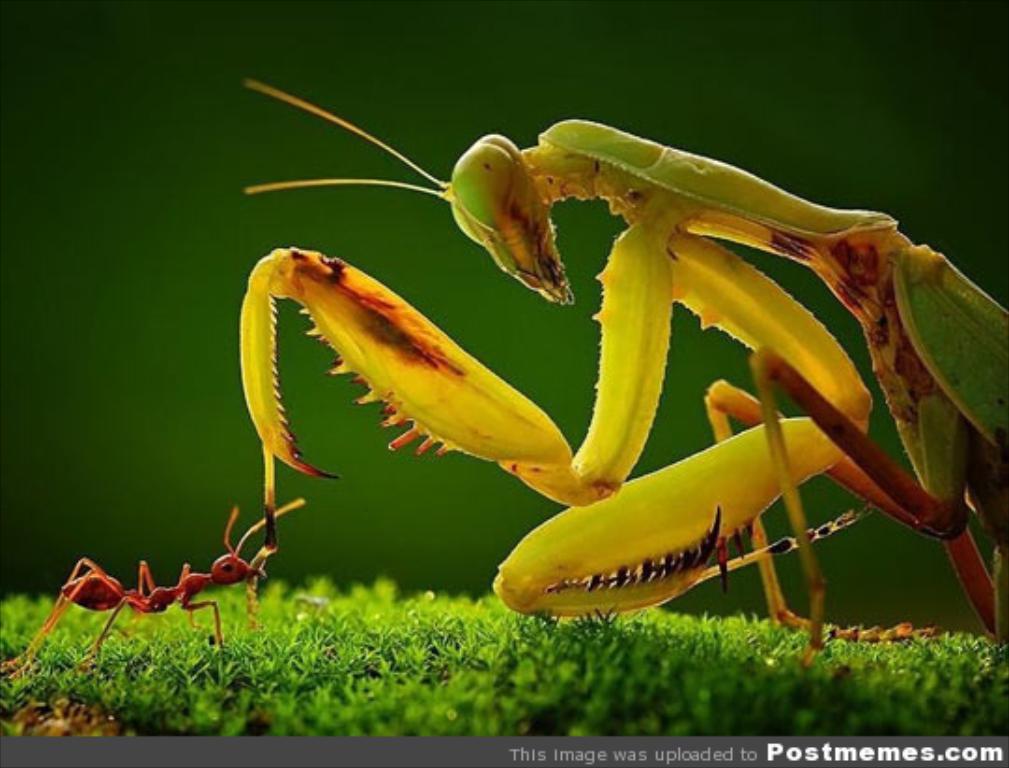In one or two sentences, can you explain what this image depicts? In this image I can see the insect in green, yellow and red color. I can see the grass, red color ant and the background is in green color. 